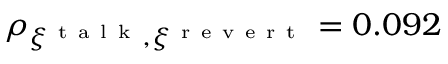<formula> <loc_0><loc_0><loc_500><loc_500>\rho _ { \xi ^ { t a l k } , \xi ^ { r e v e r t } } = 0 . 0 9 2</formula> 